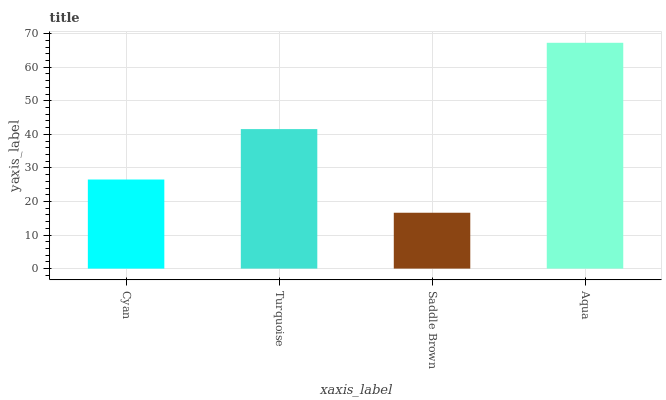Is Saddle Brown the minimum?
Answer yes or no. Yes. Is Aqua the maximum?
Answer yes or no. Yes. Is Turquoise the minimum?
Answer yes or no. No. Is Turquoise the maximum?
Answer yes or no. No. Is Turquoise greater than Cyan?
Answer yes or no. Yes. Is Cyan less than Turquoise?
Answer yes or no. Yes. Is Cyan greater than Turquoise?
Answer yes or no. No. Is Turquoise less than Cyan?
Answer yes or no. No. Is Turquoise the high median?
Answer yes or no. Yes. Is Cyan the low median?
Answer yes or no. Yes. Is Saddle Brown the high median?
Answer yes or no. No. Is Turquoise the low median?
Answer yes or no. No. 